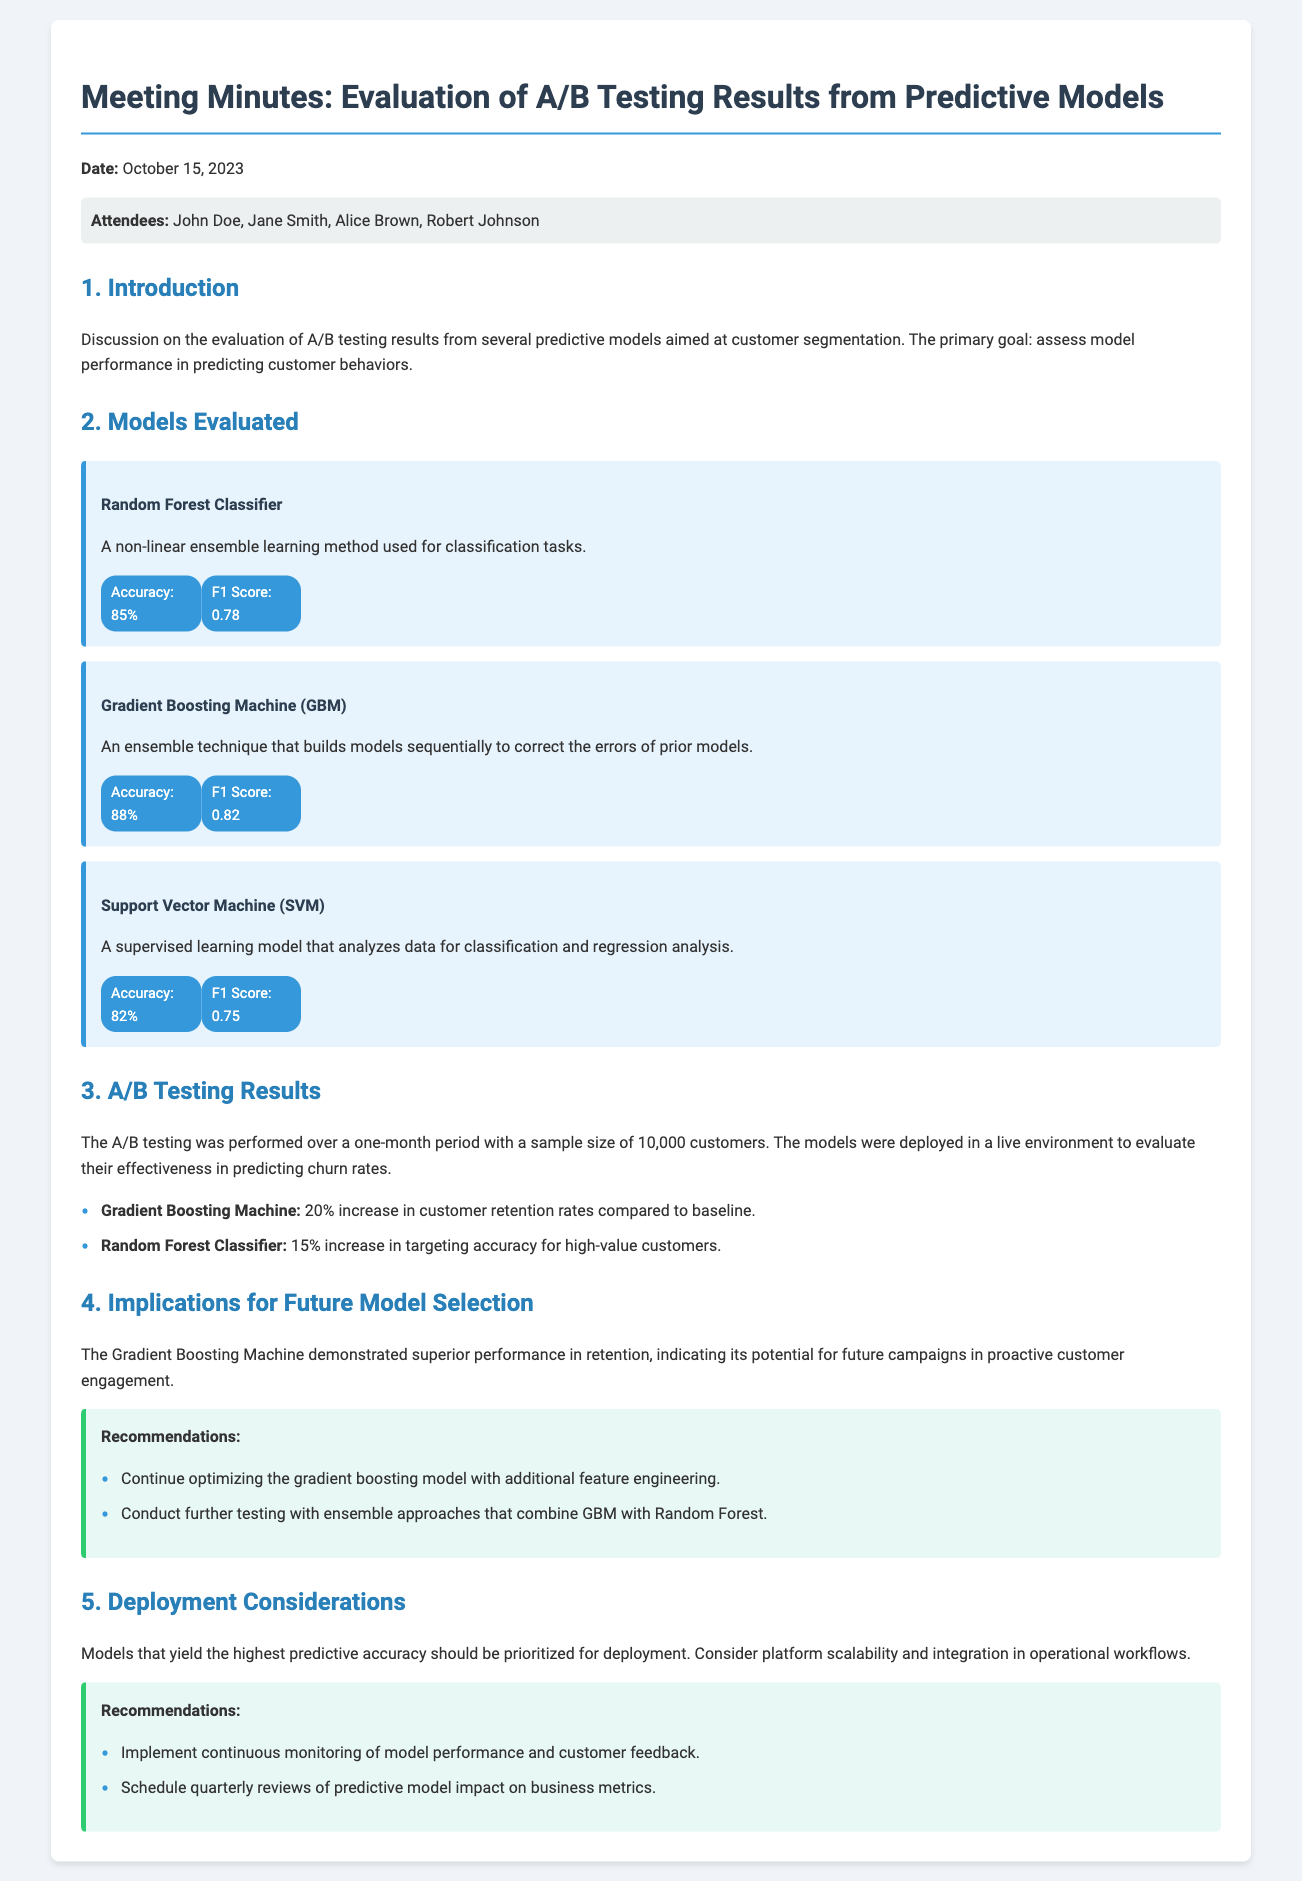What is the date of the meeting? The date of the meeting is mentioned in the document under the header "Date".
Answer: October 15, 2023 Who were the attendees of the meeting? The attendees are listed in the section labeled "Attendees" in the document.
Answer: John Doe, Jane Smith, Alice Brown, Robert Johnson What is the accuracy of the Gradient Boosting Machine? The accuracy of each model is provided in the performance metrics section for each model.
Answer: 88% What was the increase in customer retention rates due to the Gradient Boosting Machine? The document mentions the percentage increase in retention rates specifically for the Gradient Boosting Machine in the A/B testing results section.
Answer: 20% Which predictive model had the highest F1 Score? The F1 Score for each model is detailed in the performance metrics section, allowing for comparison.
Answer: Gradient Boosting Machine What recommendation is made for optimizing the models? The recommendations for future actions are listed under the recommendations section, focusing on model optimization.
Answer: Continue optimizing the gradient boosting model with additional feature engineering What is suggested for deployment considerations? The document outlines recommendations under the deployment considerations section regarding model performance monitoring.
Answer: Implement continuous monitoring of model performance and customer feedback What was the sample size used for A/B testing? The document specifies the sample size within the A/B testing section, giving a concrete number related to the tests.
Answer: 10,000 customers 